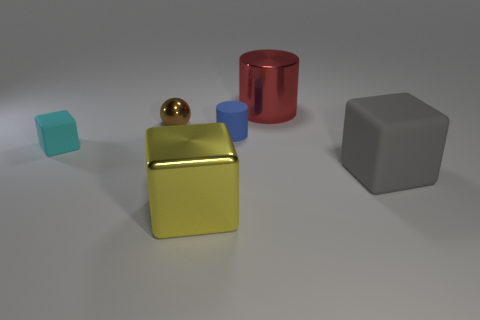Subtract 1 blocks. How many blocks are left? 2 Add 2 large purple metallic balls. How many objects exist? 8 Subtract all big cubes. How many cubes are left? 1 Subtract all cylinders. How many objects are left? 4 Subtract 0 blue balls. How many objects are left? 6 Subtract all green rubber spheres. Subtract all tiny shiny things. How many objects are left? 5 Add 1 large shiny cubes. How many large shiny cubes are left? 2 Add 5 small brown spheres. How many small brown spheres exist? 6 